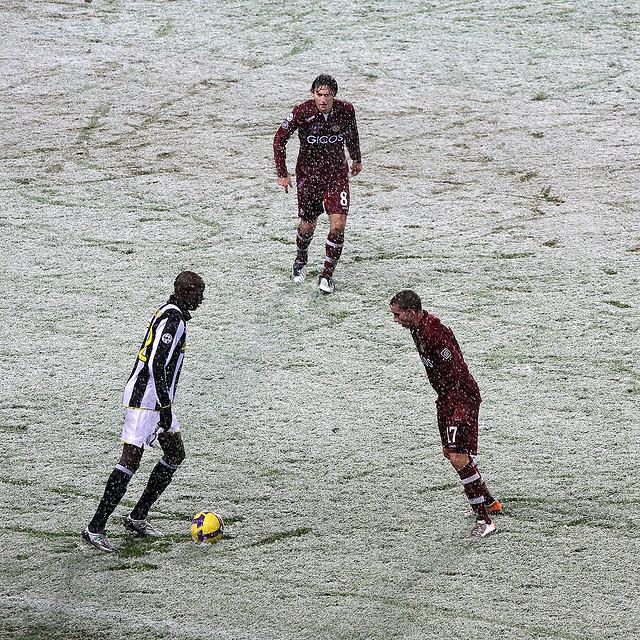What substance is covering the turf? snow 